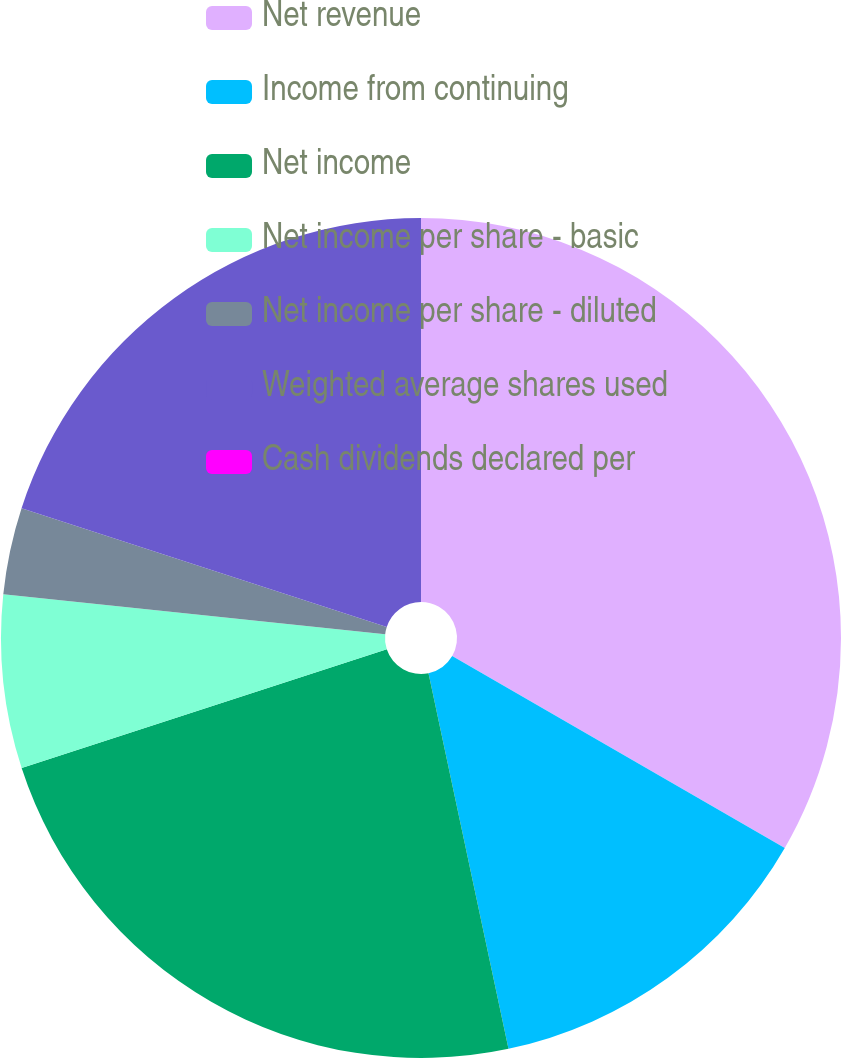<chart> <loc_0><loc_0><loc_500><loc_500><pie_chart><fcel>Net revenue<fcel>Income from continuing<fcel>Net income<fcel>Net income per share - basic<fcel>Net income per share - diluted<fcel>Weighted average shares used<fcel>Cash dividends declared per<nl><fcel>33.33%<fcel>13.33%<fcel>23.33%<fcel>6.67%<fcel>3.34%<fcel>20.0%<fcel>0.0%<nl></chart> 